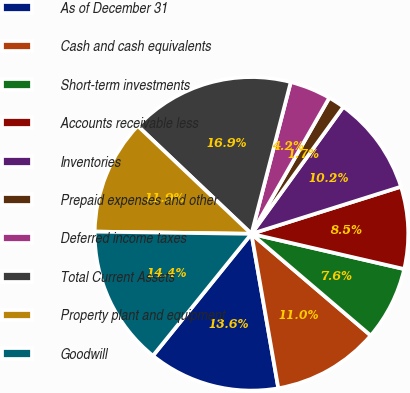Convert chart. <chart><loc_0><loc_0><loc_500><loc_500><pie_chart><fcel>As of December 31<fcel>Cash and cash equivalents<fcel>Short-term investments<fcel>Accounts receivable less<fcel>Inventories<fcel>Prepaid expenses and other<fcel>Deferred income taxes<fcel>Total Current Assets<fcel>Property plant and equipment<fcel>Goodwill<nl><fcel>13.56%<fcel>11.02%<fcel>7.63%<fcel>8.47%<fcel>10.17%<fcel>1.7%<fcel>4.24%<fcel>16.95%<fcel>11.86%<fcel>14.41%<nl></chart> 